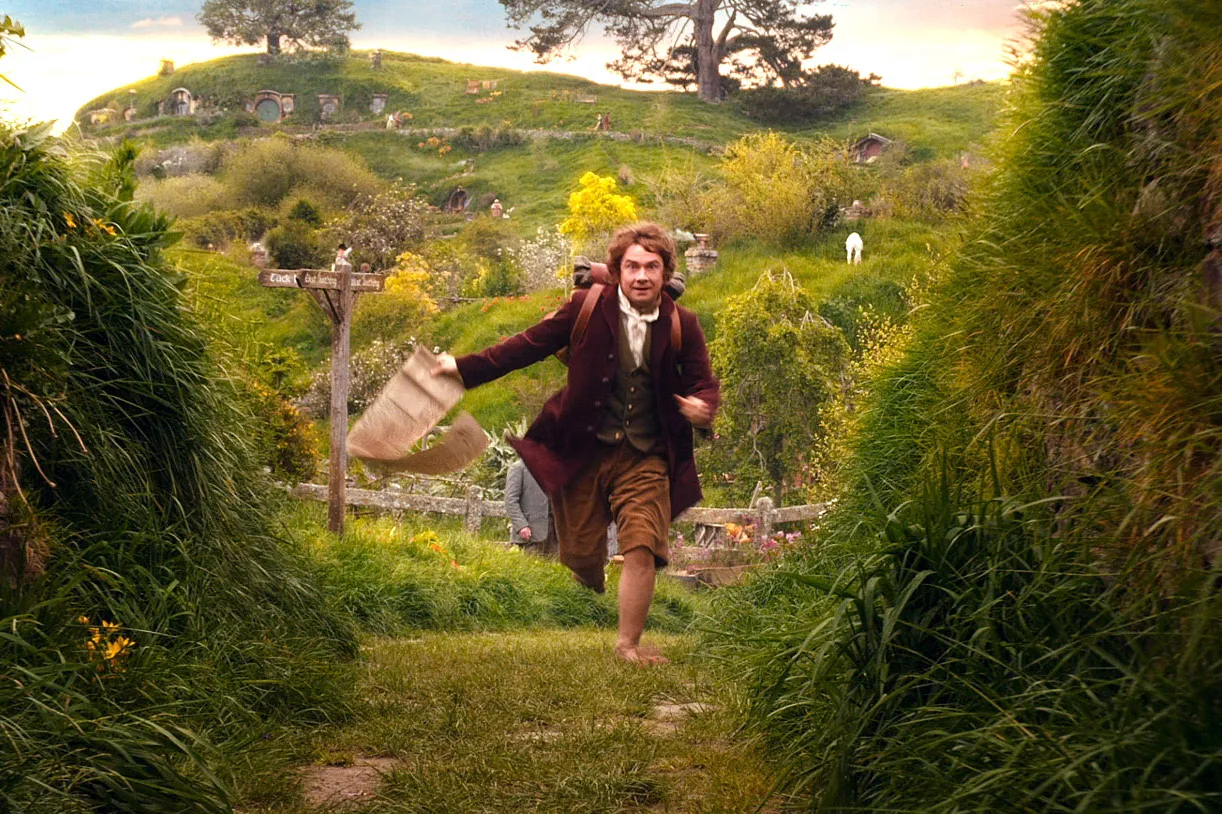What are the key elements in this picture? In this image, we see actor Martin Freeman, known for his role as Bilbo Baggins in the movie "The Hobbit: An Unexpected Journey". He is captured mid-stride, running through a lush green landscape dotted with hobbit holes. Dressed in a brown jacket, a white shirt, and brown trousers, he carries a beige bag in his right hand. His destination seems to be towards the right side of the image. A signpost in the background reads "Bag End", indicating the location within the Shire, the idyllic and peaceful home of the hobbits in the story. The image is a snapshot of a moment of urgency and adventure in the otherwise tranquil Shire. 